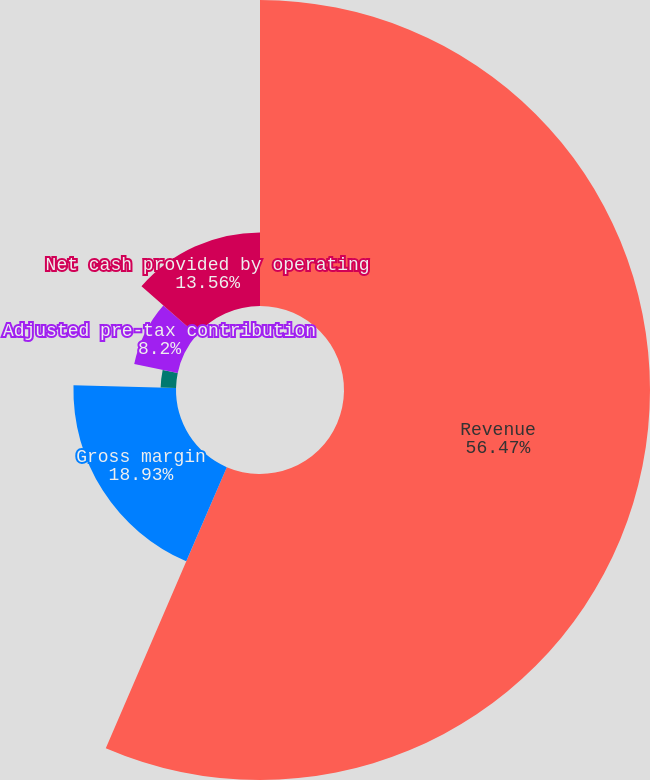Convert chart to OTSL. <chart><loc_0><loc_0><loc_500><loc_500><pie_chart><fcel>Revenue<fcel>Gross margin<fcel>Net (loss) income attributable<fcel>Adjusted pre-tax contribution<fcel>Net cash provided by operating<nl><fcel>56.47%<fcel>18.93%<fcel>2.84%<fcel>8.2%<fcel>13.56%<nl></chart> 